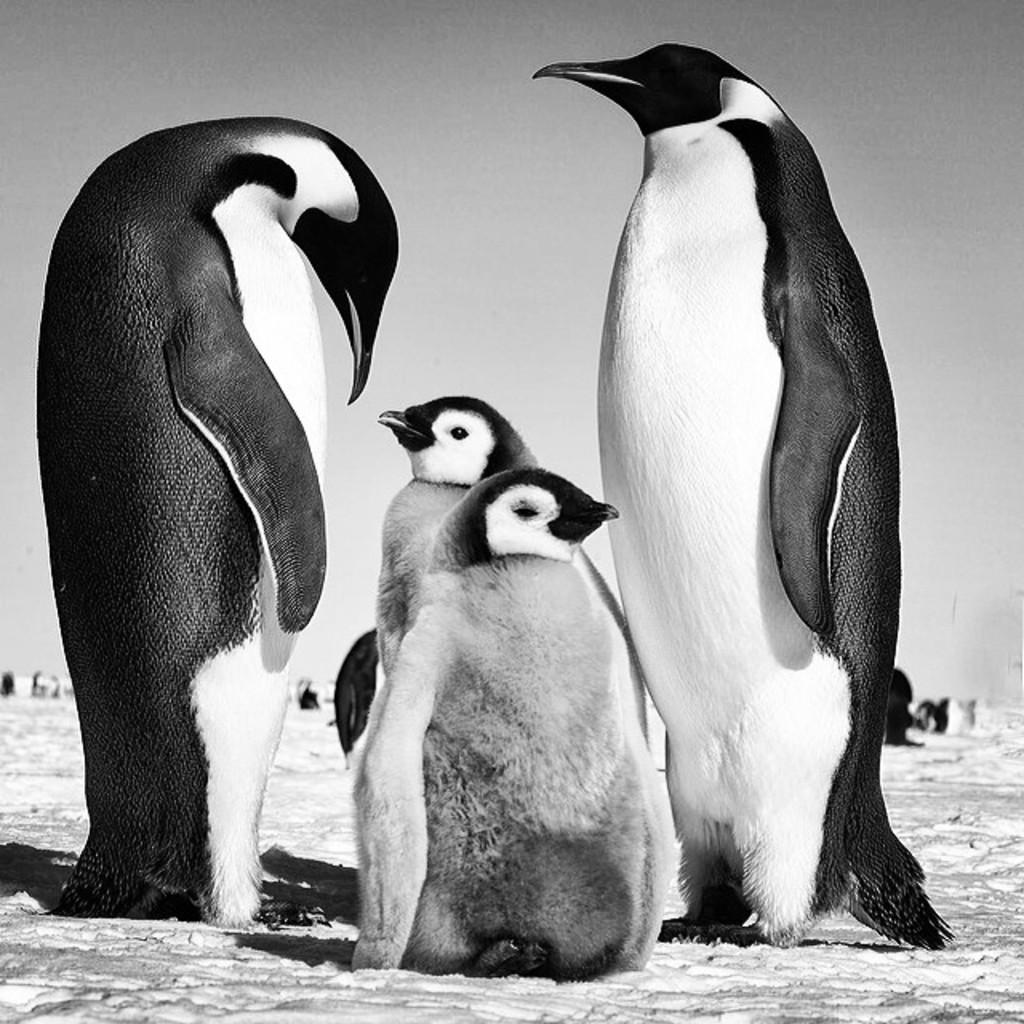How many penguins are present in the image? There are four penguins in the image, two big and two small. Can you describe the size difference between the penguins? Yes, there are two big penguins and two small penguins in the image. What is the ground made of in the image? The penguins are standing on the snow ground in the image. What type of nerve can be seen in the image? There are no nerves present in the image; it features penguins standing on snow. 